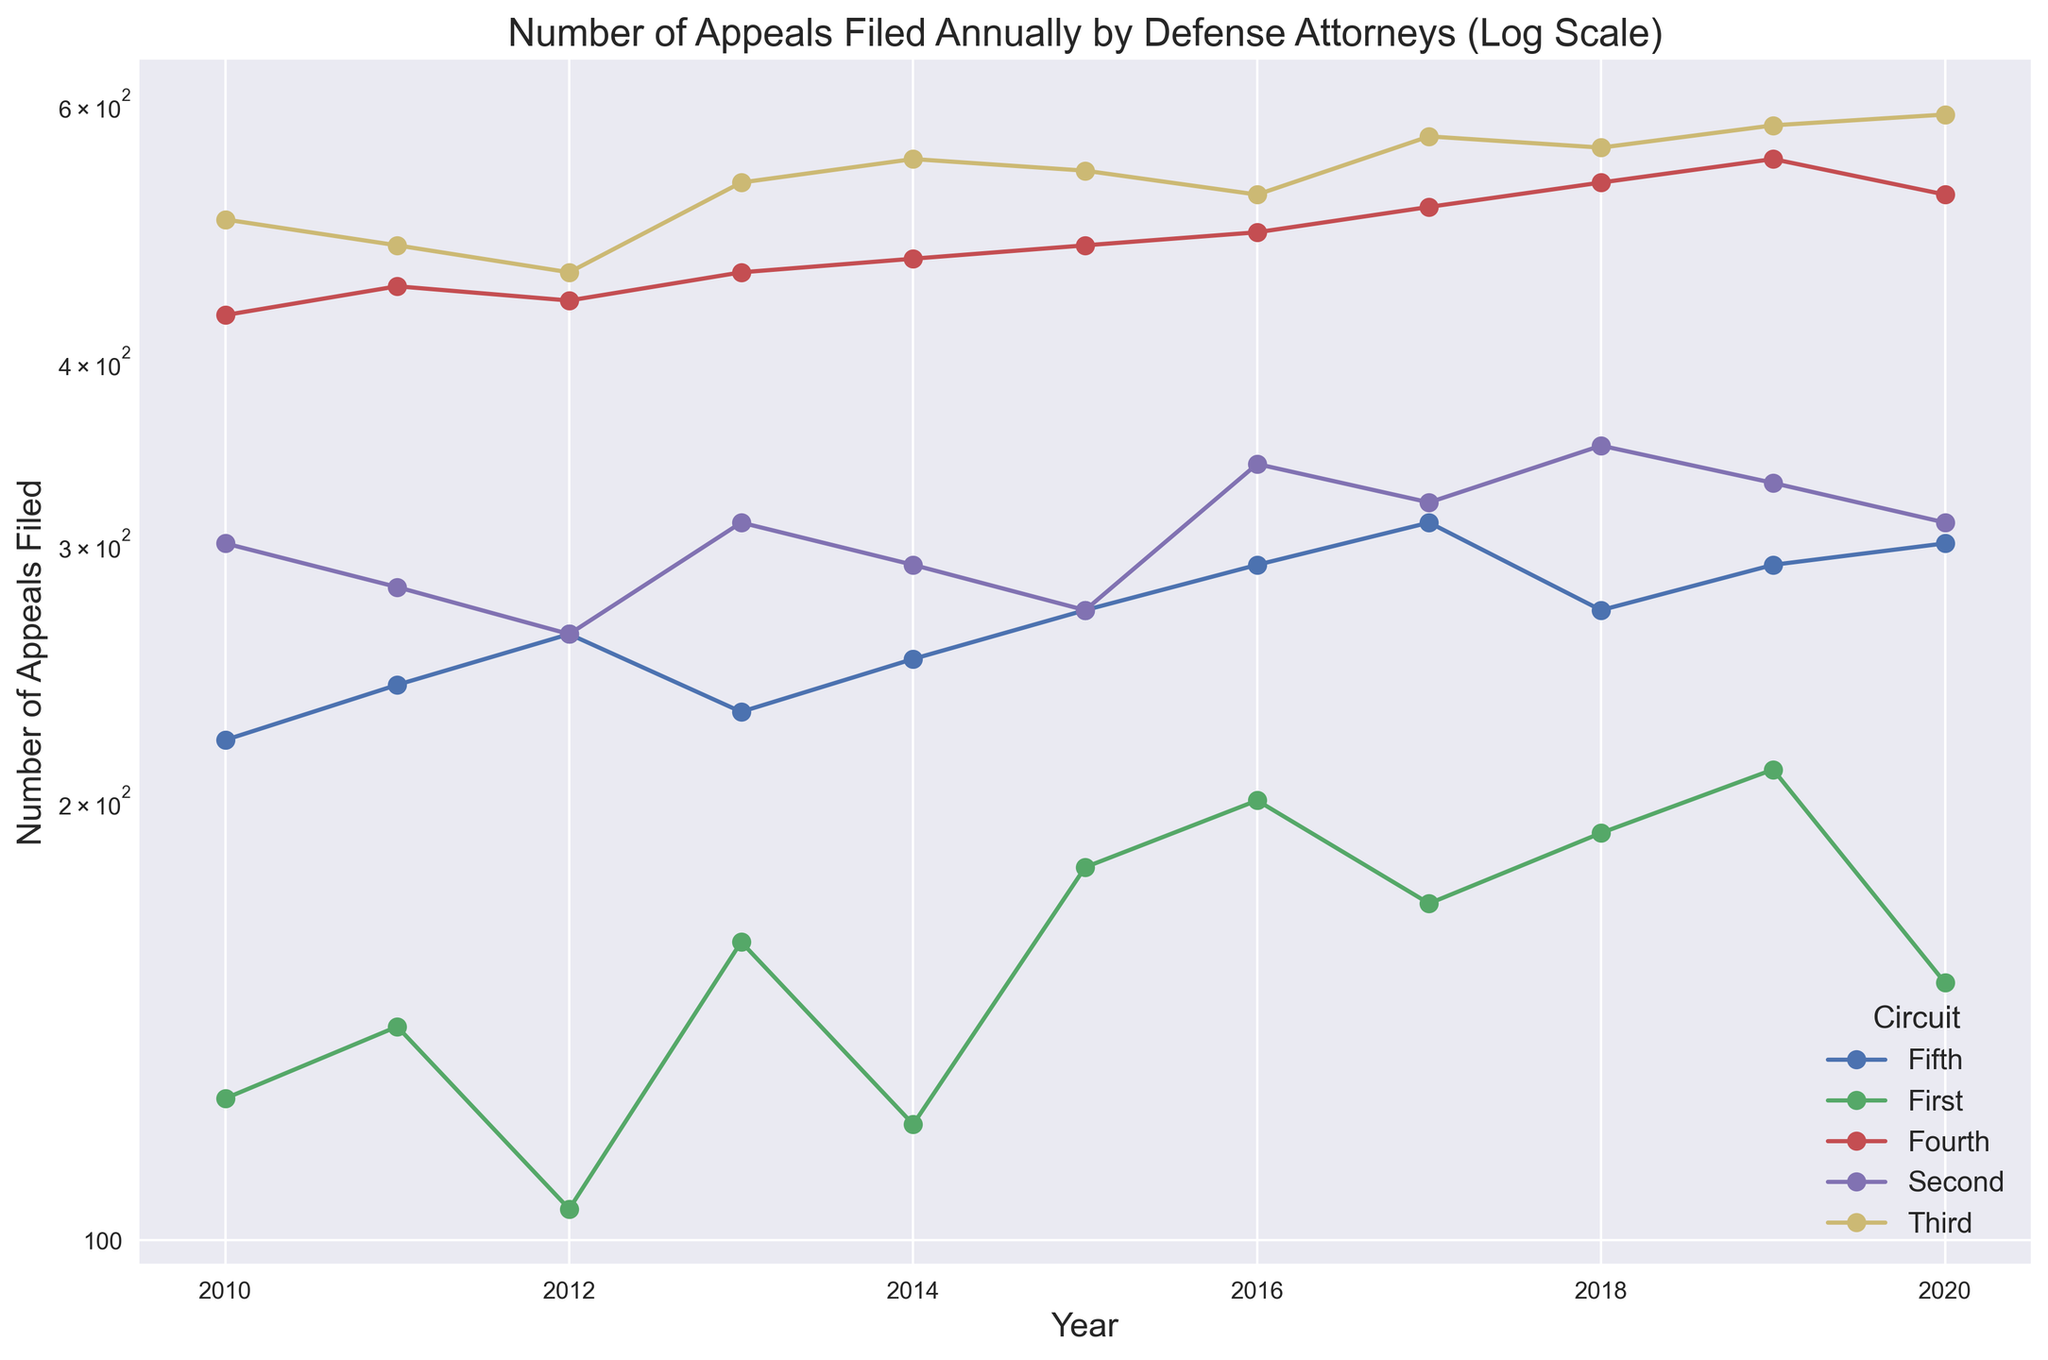What's the trend for appeals filed in the Third Circuit from 2010 to 2020? To identify the trend, observe the changes in the data points representing the Third Circuit between 2010 and 2020. The plot shows a generally upward trend, with the number of appeals increasing from 500 in 2010 to about 590 in 2020.
Answer: Upward How does the number of appeals filed in the First Circuit in 2020 compare to the number in the Fifth Circuit in 2020? Look at the plotted data for the First and Fifth Circuits in 2020. The First Circuit has about 150 appeals, while the Fifth Circuit has about 300. The First Circuit has fewer appeals compared to the Fifth Circuit.
Answer: Fewer Which Circuit had the highest number of appeals filed in 2013? Identify the data points for each Circuit in the year 2013 and compare their values. The Third Circuit had the highest number of appeals, with around 530.
Answer: Third What is the difference in the number of appeals filed between the Second and Fourth Circuits in 2015? Check the data points for the Second and Fourth Circuits in 2015. The Second Circuit had about 270 appeals and the Fourth Circuit had about 480 appeals. The difference is 480 - 270 = 210.
Answer: 210 Was there any Circuit that consistently had fewer than 200 appeals filed each year from 2010 to 2020? Look at each Circuit's line plot to see if any Circuit's line is consistently below the 200 mark. The First Circuit consistently had some values below 200 but not every year, so no Circuit consistently had fewer than 200 appeals every year.
Answer: No By how much did the number of appeals filed in the Fourth Circuit increase from 2010 to 2020? Identify the data points for the Fourth Circuit in 2010 and 2020. The number in 2010 was 430 and in 2020 was 520. The increase is 520 - 430 = 90.
Answer: 90 Which Circuit shows the largest increase in the number of appeals filed from 2016 to 2017? Compare the differences in the number of appeals between 2016 and 2017 for each Circuit. The Third Circuit shows an increase from 520 to 570, which is an increase of 50. This is the largest compared to the other circuits.
Answer: Third What is the average number of appeals filed annually in the Second Circuit from 2010 to 2020? Add the number of appeals filed in the Second Circuit for each year between 2010 and 2020, then divide by 11. The sum is (300+280+260+310+290+270+340+320+350+330+310) = 3360. The average is 3360/11 = 305.45.
Answer: 305.45 How does the rate of change in the number of appeals filed in the Fourth Circuit from 2010 to 2020 compare to that in the Fifth Circuit? For each Circuit, calculate the total change over the period: Fourth Circuit (520 - 430 = 90) and Fifth Circuit (300 - 220 = 80). The Fourth Circuit's change is 90, while the Fifth Circuit's is 80. Compare these values to conclude that the Fourth Circuit had a slightly higher rate of change.
Answer: Slightly higher in Fourth 